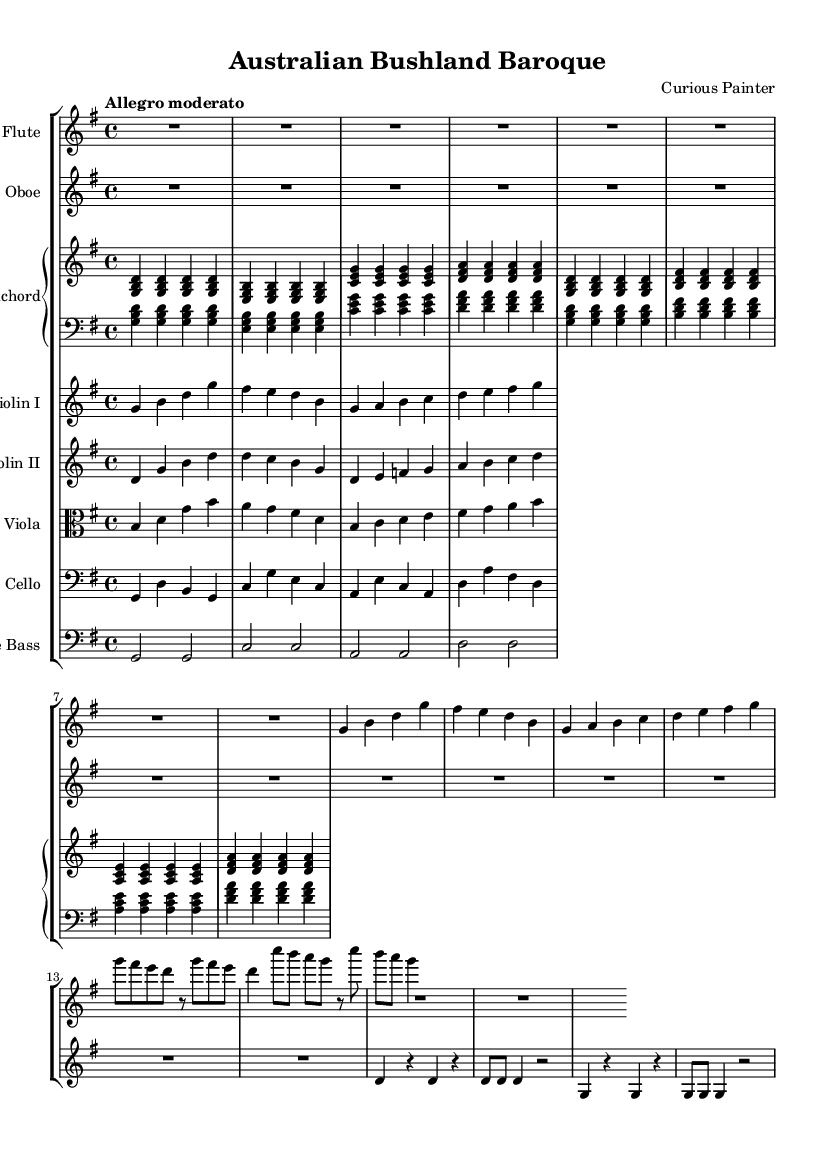What is the key signature of this music? The key signature is G major, indicated by one sharp (F#).
Answer: G major What is the time signature of this piece? The time signature is 4/4, meaning there are four beats in each measure.
Answer: 4/4 What is the tempo marking of the composition? The tempo marking is "Allegro moderato," suggesting a moderately fast pace.
Answer: Allegro moderato Which instruments are used in this composition? The instruments include flute, oboe, harpsichord, violin I, violin II, viola, cello, and double bass.
Answer: Flute, oboe, harpsichord, violin I, violin II, viola, cello, double bass How many measures does the flute part have in the main theme? The flute part has four measures in the main theme, clearly indicated in the sheet music.
Answer: Four measures What is the duration of the introduction section for the flute? The introduction section for the flute lasts for one whole measure (R1).
Answer: One measure In the bird calls, how many times does the note G appear in the flute part? The note G appears four times in the bird calls section of the flute part.
Answer: Four times 